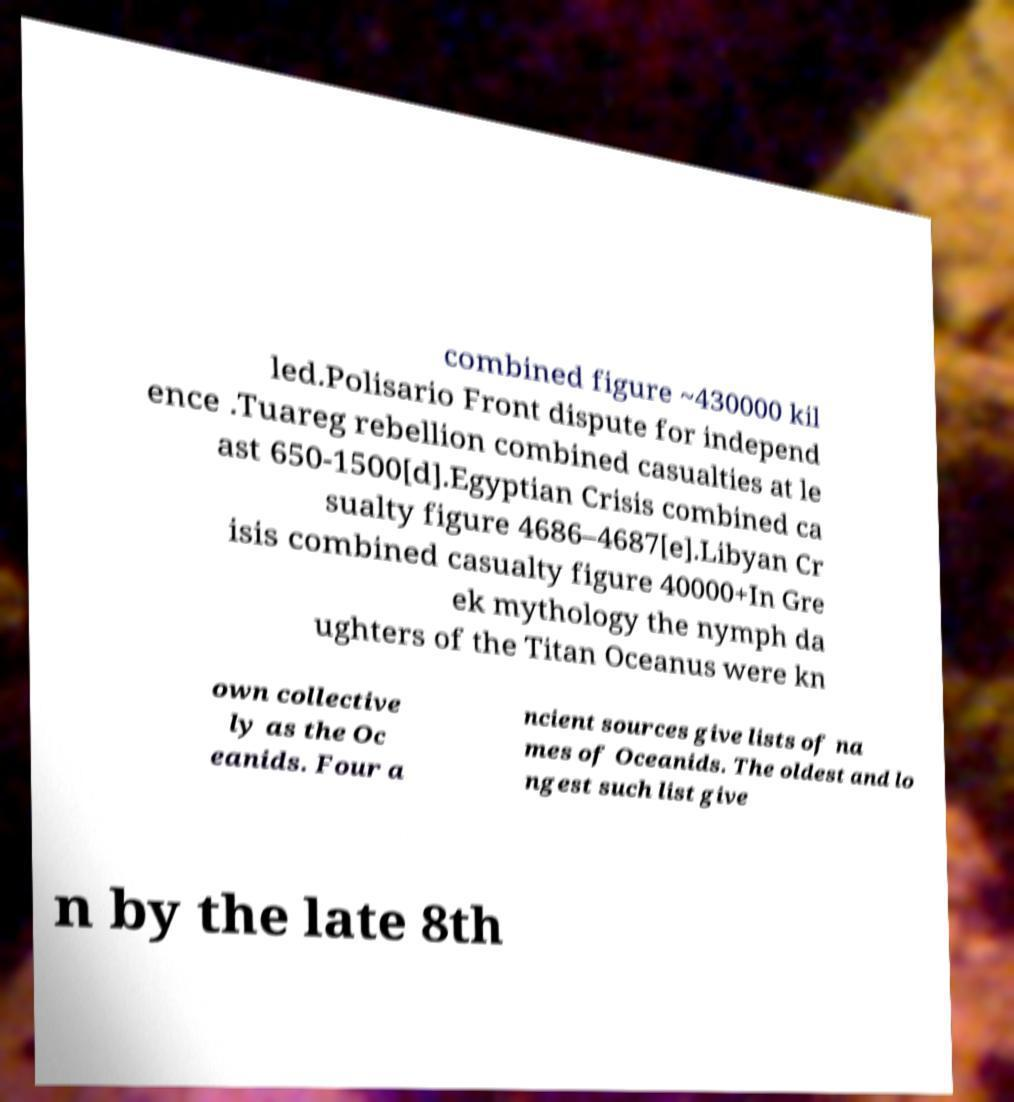Can you accurately transcribe the text from the provided image for me? combined figure ~430000 kil led.Polisario Front dispute for independ ence .Tuareg rebellion combined casualties at le ast 650-1500[d].Egyptian Crisis combined ca sualty figure 4686–4687[e].Libyan Cr isis combined casualty figure 40000+In Gre ek mythology the nymph da ughters of the Titan Oceanus were kn own collective ly as the Oc eanids. Four a ncient sources give lists of na mes of Oceanids. The oldest and lo ngest such list give n by the late 8th 